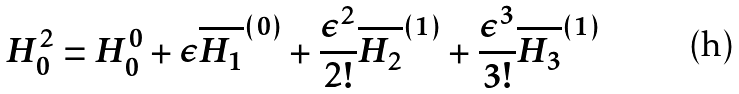Convert formula to latex. <formula><loc_0><loc_0><loc_500><loc_500>H ^ { 2 } _ { 0 } = H ^ { 0 } _ { 0 } + \epsilon \overline { H _ { 1 } } ^ { ( 0 ) } + \frac { \epsilon ^ { 2 } } { 2 ! } \overline { H _ { 2 } } ^ { ( 1 ) } + \frac { \epsilon ^ { 3 } } { 3 ! } \overline { H _ { 3 } } ^ { ( 1 ) }</formula> 